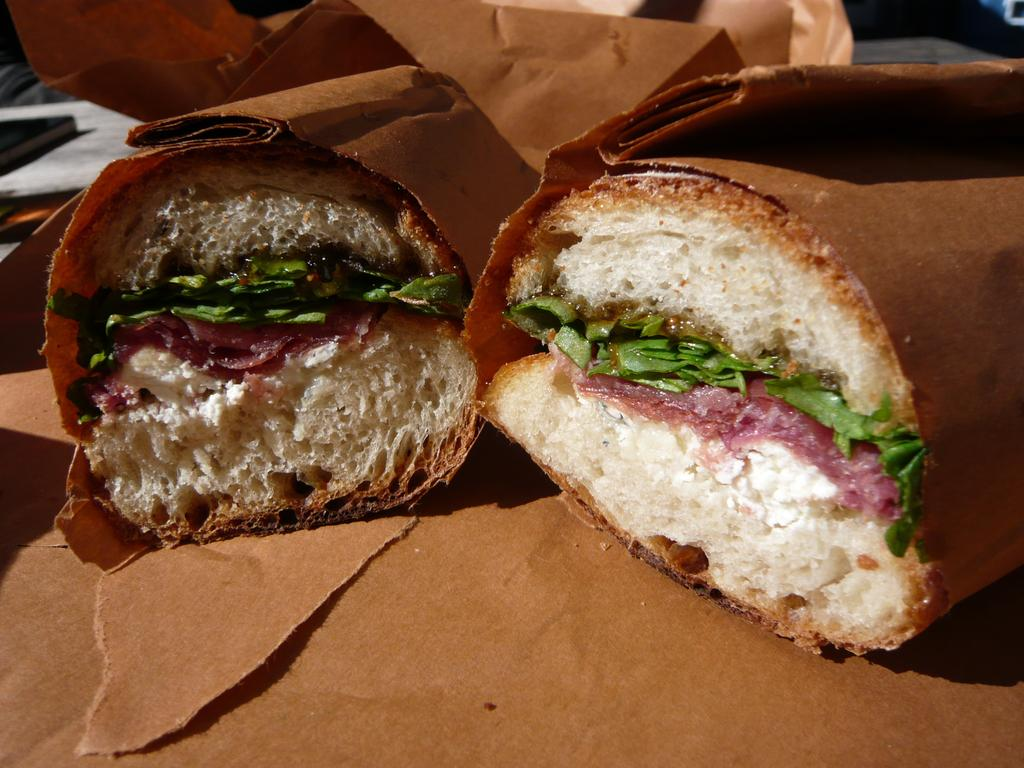What is the main subject of the image? The main subject of the image is food. How are the food items being covered in the image? The food is covered with brown covers. Where can the brown covers be seen in the image? The brown covers can be seen at the bottom and back of the image. What other object is present in the image? There is a book in the image. Can you tell me how the fireman is stretching the hose in the image? There is no fireman or hose present in the image; it features food covered with brown covers and a book. 